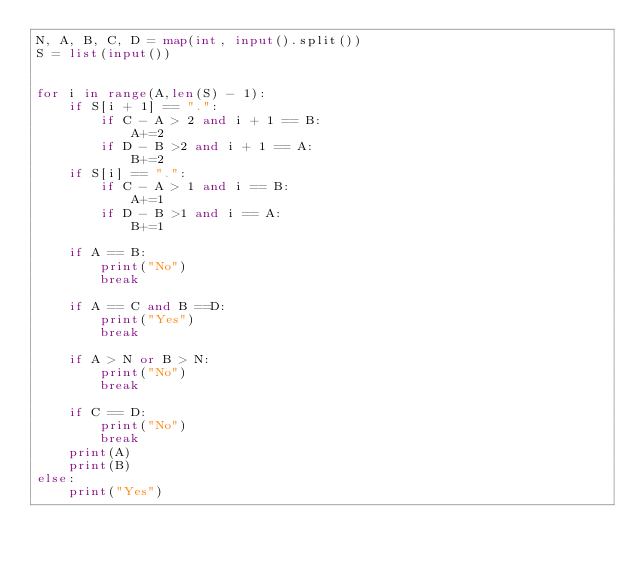Convert code to text. <code><loc_0><loc_0><loc_500><loc_500><_Python_>N, A, B, C, D = map(int, input().split())
S = list(input())

    
for i in range(A,len(S) - 1):
    if S[i + 1] == ".":
        if C - A > 2 and i + 1 == B:
            A+=2
        if D - B >2 and i + 1 == A:
            B+=2
    if S[i] == ".":
        if C - A > 1 and i == B:
            A+=1
        if D - B >1 and i == A:
            B+=1

    if A == B:
        print("No")
        break
            
    if A == C and B ==D:
        print("Yes")
        break
        
    if A > N or B > N:
        print("No")
        break

    if C == D:
        print("No")
        break
    print(A)
    print(B)
else:
    print("Yes")</code> 